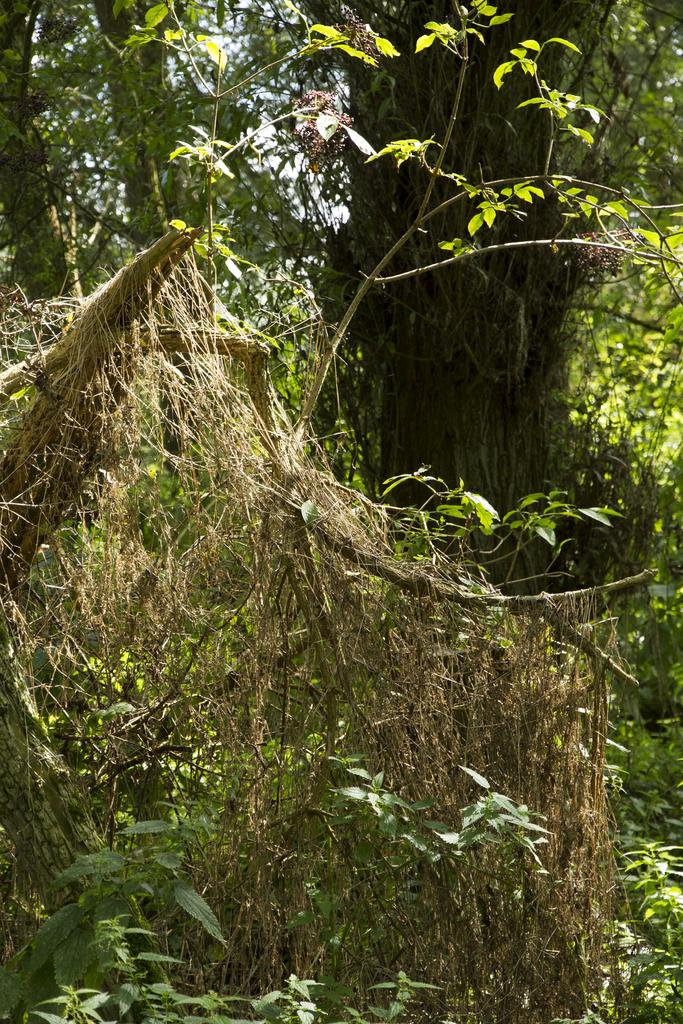What type of vegetation can be seen in the image? There are plants and trees in the image. What part of the natural environment is visible in the image? The sky is visible in the image. What type of joke is being told by the kettle in the image? There is no kettle present in the image, so it is not possible to determine what joke might be told. 